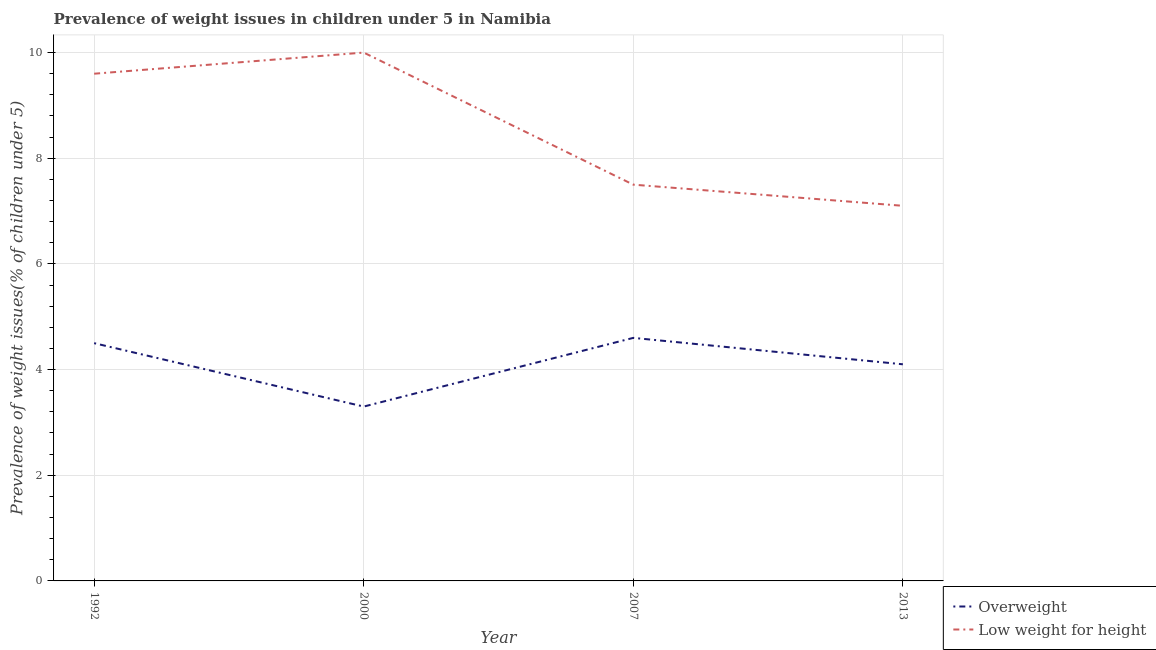How many different coloured lines are there?
Your answer should be compact. 2. Does the line corresponding to percentage of overweight children intersect with the line corresponding to percentage of underweight children?
Offer a terse response. No. Is the number of lines equal to the number of legend labels?
Offer a very short reply. Yes. Across all years, what is the maximum percentage of overweight children?
Your answer should be very brief. 4.6. Across all years, what is the minimum percentage of overweight children?
Your answer should be compact. 3.3. In which year was the percentage of overweight children minimum?
Keep it short and to the point. 2000. What is the total percentage of overweight children in the graph?
Provide a succinct answer. 16.5. What is the difference between the percentage of overweight children in 1992 and the percentage of underweight children in 2007?
Your answer should be compact. -3. What is the average percentage of overweight children per year?
Offer a very short reply. 4.12. In the year 1992, what is the difference between the percentage of underweight children and percentage of overweight children?
Provide a succinct answer. 5.1. In how many years, is the percentage of overweight children greater than 0.4 %?
Your answer should be very brief. 4. What is the ratio of the percentage of underweight children in 2000 to that in 2013?
Keep it short and to the point. 1.41. Is the percentage of underweight children in 2000 less than that in 2007?
Your answer should be compact. No. Is the difference between the percentage of underweight children in 1992 and 2013 greater than the difference between the percentage of overweight children in 1992 and 2013?
Offer a very short reply. Yes. What is the difference between the highest and the second highest percentage of overweight children?
Your response must be concise. 0.1. What is the difference between the highest and the lowest percentage of overweight children?
Your answer should be very brief. 1.3. In how many years, is the percentage of underweight children greater than the average percentage of underweight children taken over all years?
Your response must be concise. 2. Does the percentage of underweight children monotonically increase over the years?
Provide a succinct answer. No. How many years are there in the graph?
Provide a short and direct response. 4. Are the values on the major ticks of Y-axis written in scientific E-notation?
Ensure brevity in your answer.  No. Does the graph contain any zero values?
Offer a terse response. No. Does the graph contain grids?
Keep it short and to the point. Yes. Where does the legend appear in the graph?
Provide a short and direct response. Bottom right. What is the title of the graph?
Offer a terse response. Prevalence of weight issues in children under 5 in Namibia. Does "Domestic liabilities" appear as one of the legend labels in the graph?
Provide a succinct answer. No. What is the label or title of the Y-axis?
Your answer should be very brief. Prevalence of weight issues(% of children under 5). What is the Prevalence of weight issues(% of children under 5) in Overweight in 1992?
Give a very brief answer. 4.5. What is the Prevalence of weight issues(% of children under 5) of Low weight for height in 1992?
Offer a terse response. 9.6. What is the Prevalence of weight issues(% of children under 5) in Overweight in 2000?
Give a very brief answer. 3.3. What is the Prevalence of weight issues(% of children under 5) in Overweight in 2007?
Your response must be concise. 4.6. What is the Prevalence of weight issues(% of children under 5) in Overweight in 2013?
Provide a succinct answer. 4.1. What is the Prevalence of weight issues(% of children under 5) of Low weight for height in 2013?
Ensure brevity in your answer.  7.1. Across all years, what is the maximum Prevalence of weight issues(% of children under 5) in Overweight?
Ensure brevity in your answer.  4.6. Across all years, what is the maximum Prevalence of weight issues(% of children under 5) in Low weight for height?
Give a very brief answer. 10. Across all years, what is the minimum Prevalence of weight issues(% of children under 5) in Overweight?
Provide a succinct answer. 3.3. Across all years, what is the minimum Prevalence of weight issues(% of children under 5) in Low weight for height?
Provide a succinct answer. 7.1. What is the total Prevalence of weight issues(% of children under 5) in Low weight for height in the graph?
Offer a very short reply. 34.2. What is the difference between the Prevalence of weight issues(% of children under 5) of Overweight in 1992 and that in 2000?
Keep it short and to the point. 1.2. What is the difference between the Prevalence of weight issues(% of children under 5) of Overweight in 1992 and that in 2007?
Provide a succinct answer. -0.1. What is the difference between the Prevalence of weight issues(% of children under 5) of Low weight for height in 1992 and that in 2007?
Provide a succinct answer. 2.1. What is the difference between the Prevalence of weight issues(% of children under 5) of Low weight for height in 1992 and that in 2013?
Keep it short and to the point. 2.5. What is the difference between the Prevalence of weight issues(% of children under 5) in Overweight in 2000 and that in 2007?
Your response must be concise. -1.3. What is the difference between the Prevalence of weight issues(% of children under 5) in Overweight in 2000 and that in 2013?
Your answer should be compact. -0.8. What is the difference between the Prevalence of weight issues(% of children under 5) of Low weight for height in 2000 and that in 2013?
Provide a short and direct response. 2.9. What is the difference between the Prevalence of weight issues(% of children under 5) in Overweight in 2007 and that in 2013?
Your answer should be very brief. 0.5. What is the difference between the Prevalence of weight issues(% of children under 5) in Low weight for height in 2007 and that in 2013?
Ensure brevity in your answer.  0.4. What is the difference between the Prevalence of weight issues(% of children under 5) of Overweight in 1992 and the Prevalence of weight issues(% of children under 5) of Low weight for height in 2007?
Give a very brief answer. -3. What is the average Prevalence of weight issues(% of children under 5) in Overweight per year?
Your answer should be compact. 4.12. What is the average Prevalence of weight issues(% of children under 5) of Low weight for height per year?
Make the answer very short. 8.55. In the year 1992, what is the difference between the Prevalence of weight issues(% of children under 5) of Overweight and Prevalence of weight issues(% of children under 5) of Low weight for height?
Give a very brief answer. -5.1. In the year 2000, what is the difference between the Prevalence of weight issues(% of children under 5) in Overweight and Prevalence of weight issues(% of children under 5) in Low weight for height?
Provide a succinct answer. -6.7. What is the ratio of the Prevalence of weight issues(% of children under 5) in Overweight in 1992 to that in 2000?
Offer a very short reply. 1.36. What is the ratio of the Prevalence of weight issues(% of children under 5) in Low weight for height in 1992 to that in 2000?
Your answer should be compact. 0.96. What is the ratio of the Prevalence of weight issues(% of children under 5) in Overweight in 1992 to that in 2007?
Keep it short and to the point. 0.98. What is the ratio of the Prevalence of weight issues(% of children under 5) of Low weight for height in 1992 to that in 2007?
Provide a succinct answer. 1.28. What is the ratio of the Prevalence of weight issues(% of children under 5) of Overweight in 1992 to that in 2013?
Keep it short and to the point. 1.1. What is the ratio of the Prevalence of weight issues(% of children under 5) in Low weight for height in 1992 to that in 2013?
Ensure brevity in your answer.  1.35. What is the ratio of the Prevalence of weight issues(% of children under 5) of Overweight in 2000 to that in 2007?
Your answer should be very brief. 0.72. What is the ratio of the Prevalence of weight issues(% of children under 5) in Overweight in 2000 to that in 2013?
Offer a terse response. 0.8. What is the ratio of the Prevalence of weight issues(% of children under 5) of Low weight for height in 2000 to that in 2013?
Ensure brevity in your answer.  1.41. What is the ratio of the Prevalence of weight issues(% of children under 5) in Overweight in 2007 to that in 2013?
Your answer should be very brief. 1.12. What is the ratio of the Prevalence of weight issues(% of children under 5) in Low weight for height in 2007 to that in 2013?
Provide a short and direct response. 1.06. What is the difference between the highest and the second highest Prevalence of weight issues(% of children under 5) in Overweight?
Provide a succinct answer. 0.1. What is the difference between the highest and the second highest Prevalence of weight issues(% of children under 5) of Low weight for height?
Provide a short and direct response. 0.4. 